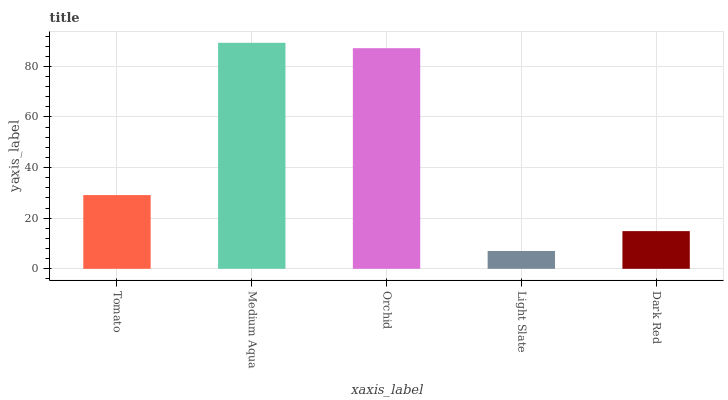Is Orchid the minimum?
Answer yes or no. No. Is Orchid the maximum?
Answer yes or no. No. Is Medium Aqua greater than Orchid?
Answer yes or no. Yes. Is Orchid less than Medium Aqua?
Answer yes or no. Yes. Is Orchid greater than Medium Aqua?
Answer yes or no. No. Is Medium Aqua less than Orchid?
Answer yes or no. No. Is Tomato the high median?
Answer yes or no. Yes. Is Tomato the low median?
Answer yes or no. Yes. Is Dark Red the high median?
Answer yes or no. No. Is Orchid the low median?
Answer yes or no. No. 